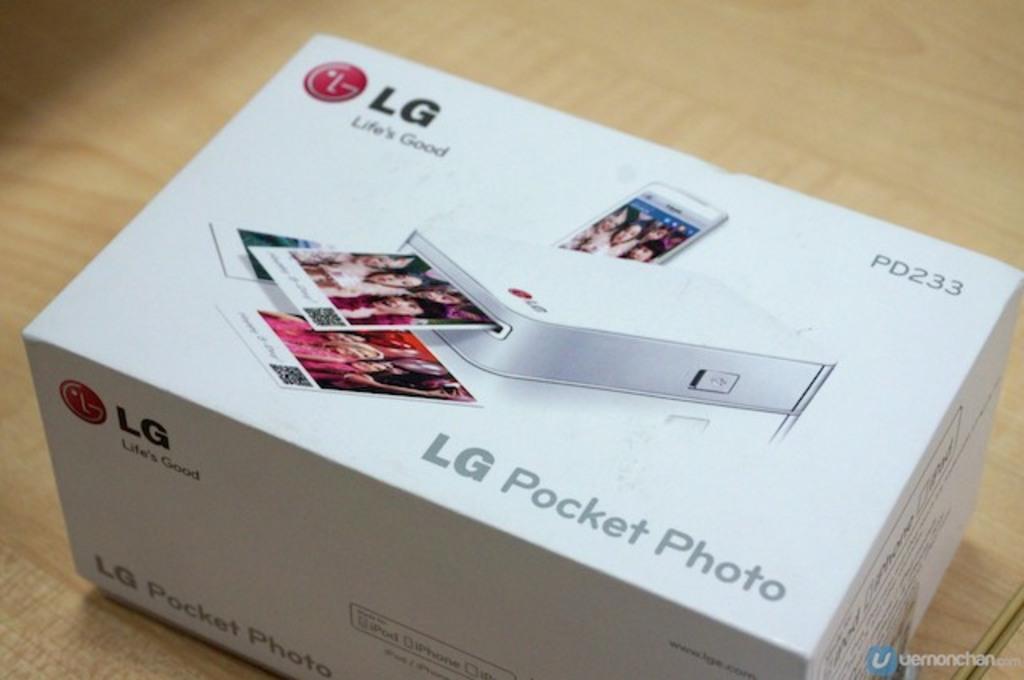What company makes this printer?
Keep it short and to the point. Lg. 